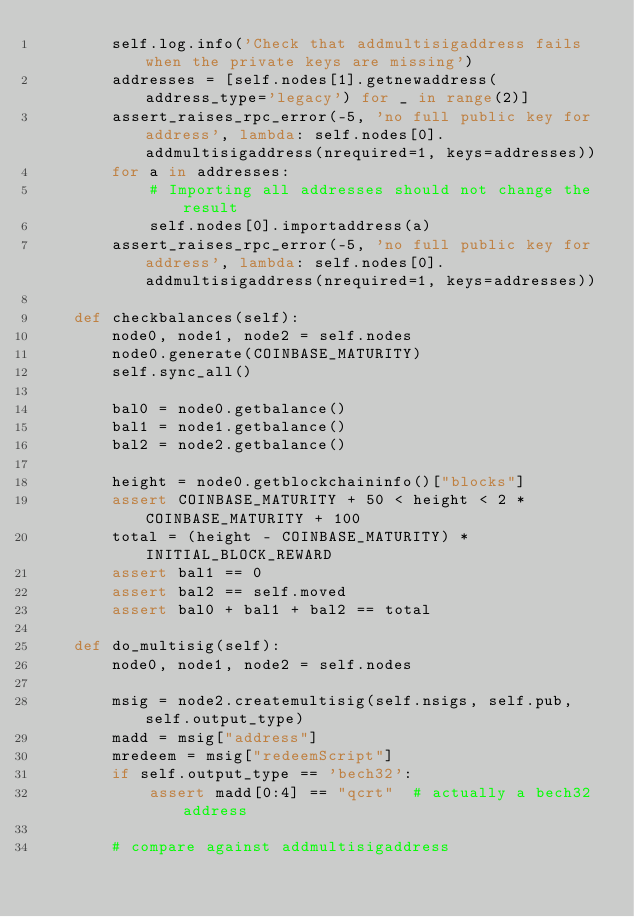<code> <loc_0><loc_0><loc_500><loc_500><_Python_>        self.log.info('Check that addmultisigaddress fails when the private keys are missing')
        addresses = [self.nodes[1].getnewaddress(address_type='legacy') for _ in range(2)]
        assert_raises_rpc_error(-5, 'no full public key for address', lambda: self.nodes[0].addmultisigaddress(nrequired=1, keys=addresses))
        for a in addresses:
            # Importing all addresses should not change the result
            self.nodes[0].importaddress(a)
        assert_raises_rpc_error(-5, 'no full public key for address', lambda: self.nodes[0].addmultisigaddress(nrequired=1, keys=addresses))

    def checkbalances(self):
        node0, node1, node2 = self.nodes
        node0.generate(COINBASE_MATURITY)
        self.sync_all()

        bal0 = node0.getbalance()
        bal1 = node1.getbalance()
        bal2 = node2.getbalance()

        height = node0.getblockchaininfo()["blocks"]
        assert COINBASE_MATURITY + 50 < height < 2 * COINBASE_MATURITY + 100
        total = (height - COINBASE_MATURITY) * INITIAL_BLOCK_REWARD
        assert bal1 == 0
        assert bal2 == self.moved
        assert bal0 + bal1 + bal2 == total

    def do_multisig(self):
        node0, node1, node2 = self.nodes

        msig = node2.createmultisig(self.nsigs, self.pub, self.output_type)
        madd = msig["address"]
        mredeem = msig["redeemScript"]
        if self.output_type == 'bech32':
            assert madd[0:4] == "qcrt"  # actually a bech32 address

        # compare against addmultisigaddress</code> 